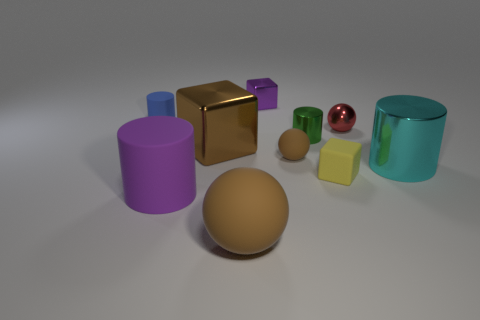Subtract all tiny cubes. How many cubes are left? 1 Subtract all cyan cylinders. How many cylinders are left? 3 Subtract all balls. How many objects are left? 7 Subtract all yellow cubes. How many brown cylinders are left? 0 Subtract 1 blocks. How many blocks are left? 2 Subtract all brown balls. Subtract all gray cylinders. How many balls are left? 1 Subtract all big brown matte balls. Subtract all balls. How many objects are left? 6 Add 5 large rubber spheres. How many large rubber spheres are left? 6 Add 1 rubber cylinders. How many rubber cylinders exist? 3 Subtract 0 gray blocks. How many objects are left? 10 